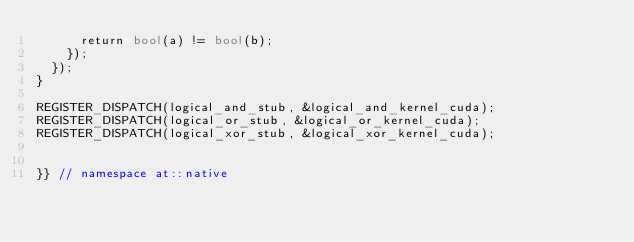Convert code to text. <code><loc_0><loc_0><loc_500><loc_500><_Cuda_>      return bool(a) != bool(b);
    });
  });
}

REGISTER_DISPATCH(logical_and_stub, &logical_and_kernel_cuda);
REGISTER_DISPATCH(logical_or_stub, &logical_or_kernel_cuda);
REGISTER_DISPATCH(logical_xor_stub, &logical_xor_kernel_cuda);


}} // namespace at::native
</code> 